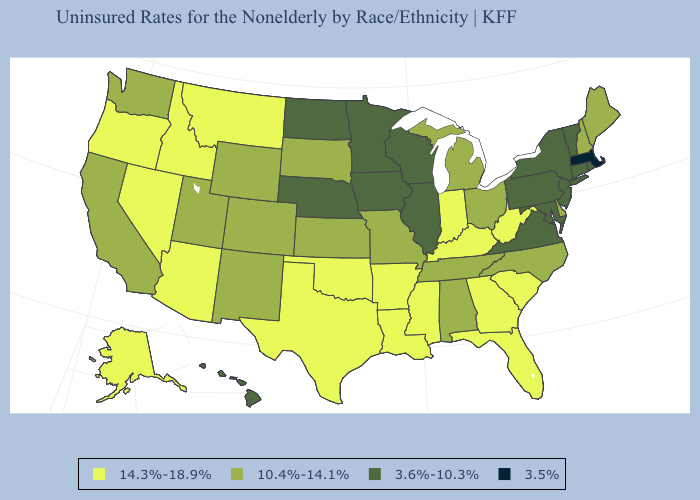What is the value of California?
Answer briefly. 10.4%-14.1%. Name the states that have a value in the range 3.6%-10.3%?
Short answer required. Connecticut, Hawaii, Illinois, Iowa, Maryland, Minnesota, Nebraska, New Jersey, New York, North Dakota, Pennsylvania, Rhode Island, Vermont, Virginia, Wisconsin. Does the first symbol in the legend represent the smallest category?
Give a very brief answer. No. Does Wyoming have the lowest value in the USA?
Keep it brief. No. Does the first symbol in the legend represent the smallest category?
Answer briefly. No. Name the states that have a value in the range 14.3%-18.9%?
Be succinct. Alaska, Arizona, Arkansas, Florida, Georgia, Idaho, Indiana, Kentucky, Louisiana, Mississippi, Montana, Nevada, Oklahoma, Oregon, South Carolina, Texas, West Virginia. Is the legend a continuous bar?
Answer briefly. No. What is the value of Delaware?
Write a very short answer. 10.4%-14.1%. Does Wisconsin have a lower value than Minnesota?
Keep it brief. No. Is the legend a continuous bar?
Concise answer only. No. What is the highest value in the USA?
Give a very brief answer. 14.3%-18.9%. Does Massachusetts have the lowest value in the USA?
Be succinct. Yes. Does the map have missing data?
Write a very short answer. No. Among the states that border Washington , which have the highest value?
Write a very short answer. Idaho, Oregon. What is the highest value in the MidWest ?
Give a very brief answer. 14.3%-18.9%. 